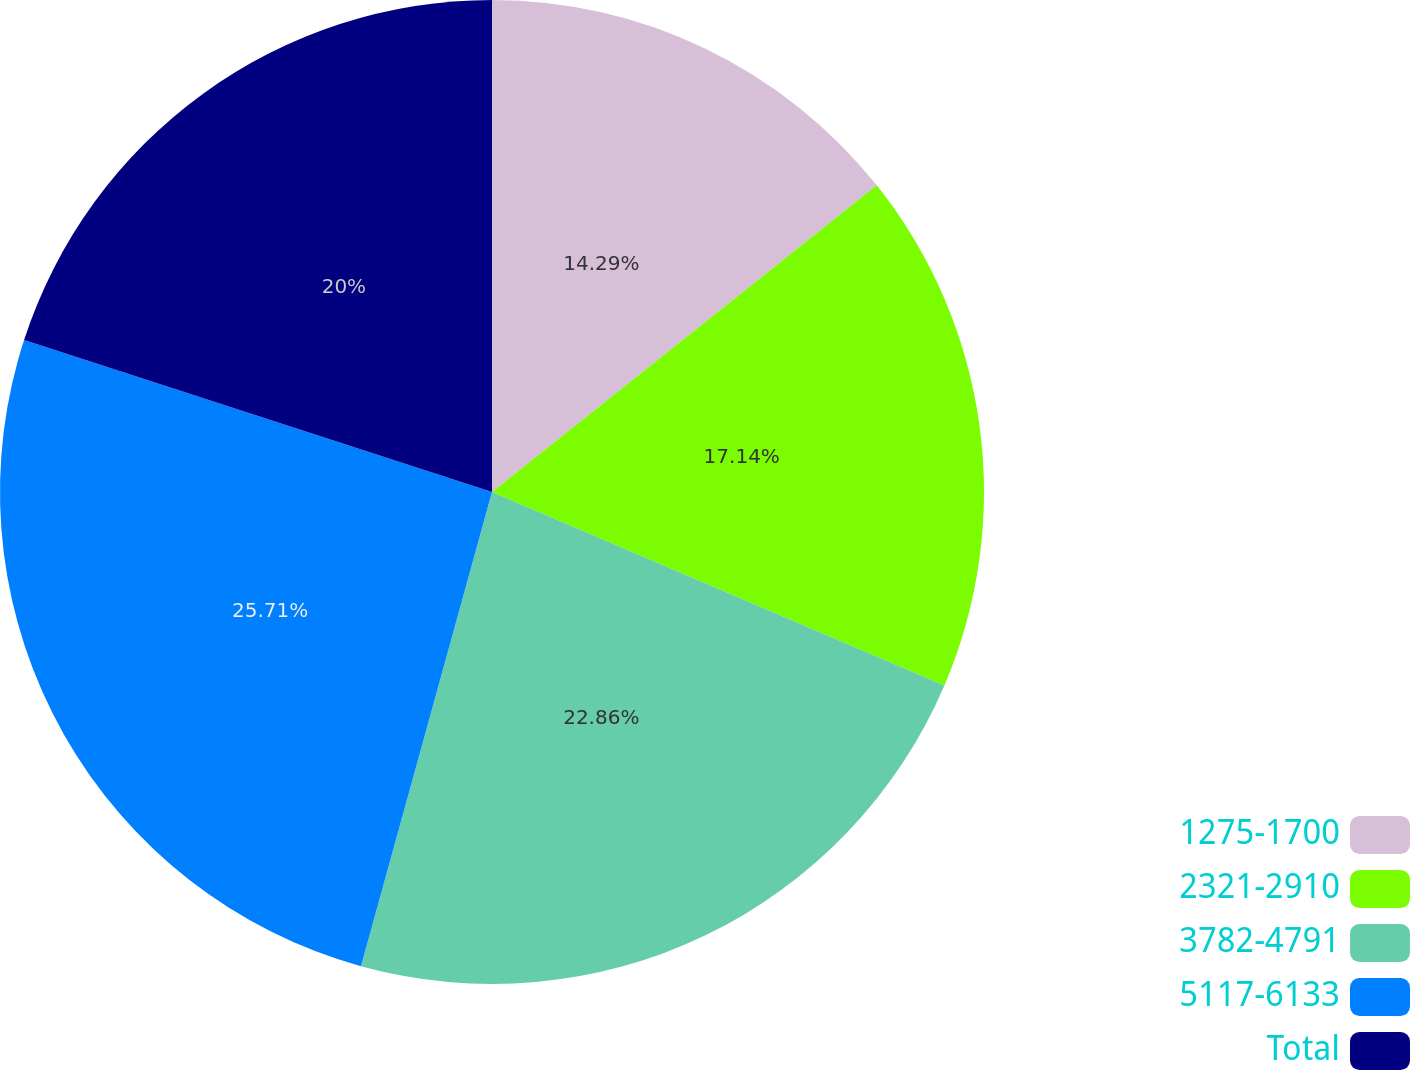Convert chart to OTSL. <chart><loc_0><loc_0><loc_500><loc_500><pie_chart><fcel>1275-1700<fcel>2321-2910<fcel>3782-4791<fcel>5117-6133<fcel>Total<nl><fcel>14.29%<fcel>17.14%<fcel>22.86%<fcel>25.71%<fcel>20.0%<nl></chart> 